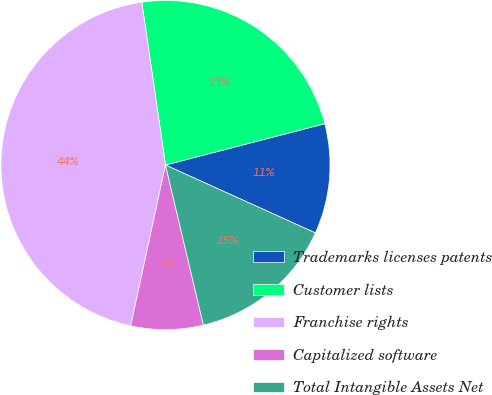<chart> <loc_0><loc_0><loc_500><loc_500><pie_chart><fcel>Trademarks licenses patents<fcel>Customer lists<fcel>Franchise rights<fcel>Capitalized software<fcel>Total Intangible Assets Net<nl><fcel>10.81%<fcel>23.26%<fcel>44.31%<fcel>7.09%<fcel>14.53%<nl></chart> 